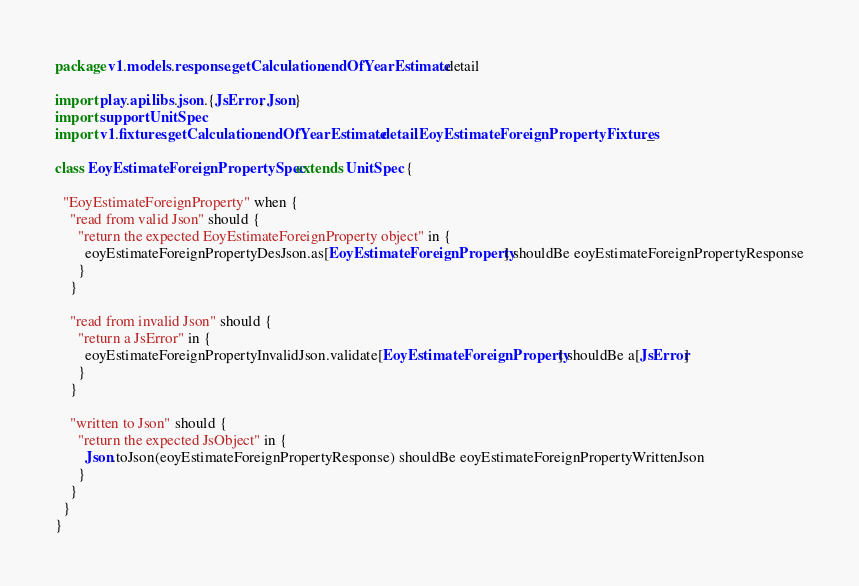Convert code to text. <code><loc_0><loc_0><loc_500><loc_500><_Scala_>
package v1.models.response.getCalculation.endOfYearEstimate.detail

import play.api.libs.json.{JsError, Json}
import support.UnitSpec
import v1.fixtures.getCalculation.endOfYearEstimate.detail.EoyEstimateForeignPropertyFixtures._

class EoyEstimateForeignPropertySpec extends UnitSpec {

  "EoyEstimateForeignProperty" when {
    "read from valid Json" should {
      "return the expected EoyEstimateForeignProperty object" in {
        eoyEstimateForeignPropertyDesJson.as[EoyEstimateForeignProperty] shouldBe eoyEstimateForeignPropertyResponse
      }
    }

    "read from invalid Json" should {
      "return a JsError" in {
        eoyEstimateForeignPropertyInvalidJson.validate[EoyEstimateForeignProperty] shouldBe a[JsError]
      }
    }

    "written to Json" should {
      "return the expected JsObject" in {
        Json.toJson(eoyEstimateForeignPropertyResponse) shouldBe eoyEstimateForeignPropertyWrittenJson
      }
    }
  }
}</code> 